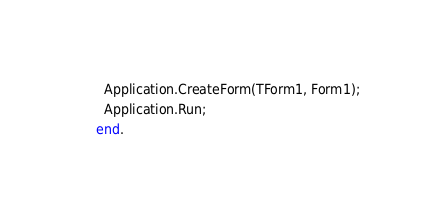<code> <loc_0><loc_0><loc_500><loc_500><_Pascal_>  Application.CreateForm(TForm1, Form1);
  Application.Run;
end.
</code> 